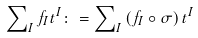<formula> <loc_0><loc_0><loc_500><loc_500>\sum \nolimits _ { I } f _ { I } t ^ { I } \colon = \sum \nolimits _ { I } \left ( f _ { I } \circ \sigma \right ) t ^ { I }</formula> 